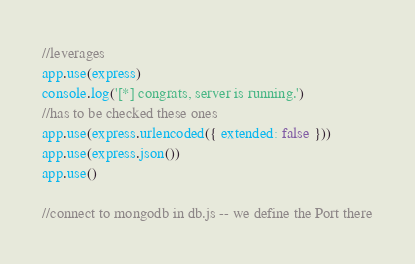Convert code to text. <code><loc_0><loc_0><loc_500><loc_500><_JavaScript_>//leverages
app.use(express)
console.log('[*] congrats, server is running.')
//has to be checked these ones
app.use(express.urlencoded({ extended: false }))
app.use(express.json())
app.use()

//connect to mongodb in db.js -- we define the Port there
</code> 